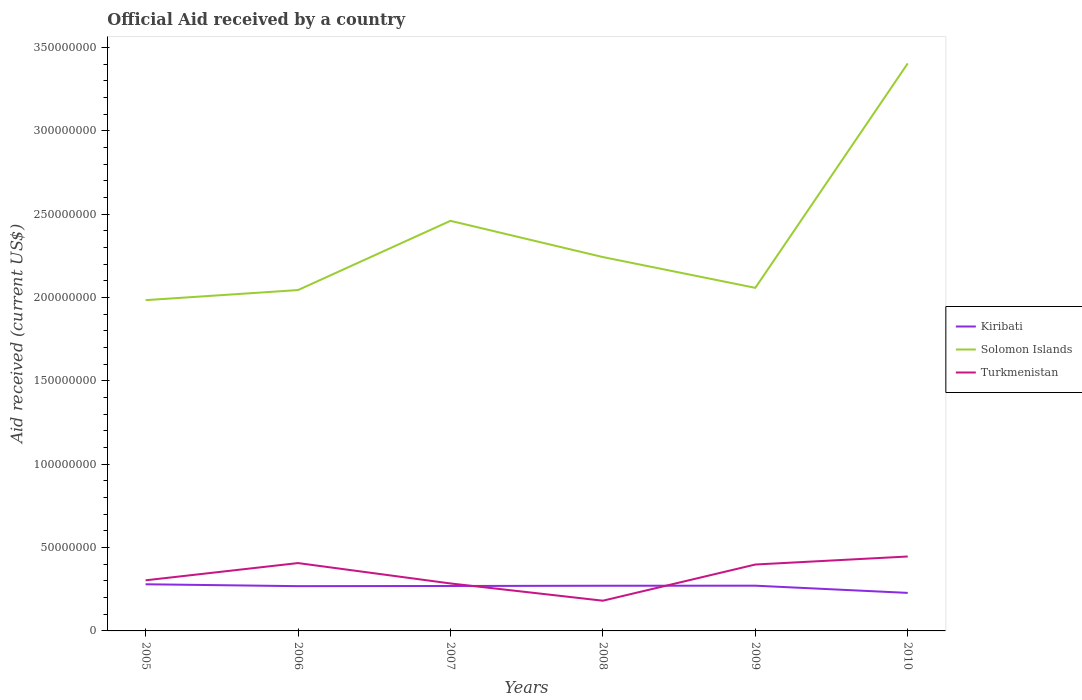How many different coloured lines are there?
Offer a very short reply. 3. Does the line corresponding to Solomon Islands intersect with the line corresponding to Turkmenistan?
Keep it short and to the point. No. Is the number of lines equal to the number of legend labels?
Offer a terse response. Yes. Across all years, what is the maximum net official aid received in Kiribati?
Your response must be concise. 2.28e+07. In which year was the net official aid received in Kiribati maximum?
Your answer should be compact. 2010. What is the total net official aid received in Kiribati in the graph?
Provide a succinct answer. 4.32e+06. What is the difference between the highest and the second highest net official aid received in Turkmenistan?
Offer a very short reply. 2.65e+07. Is the net official aid received in Kiribati strictly greater than the net official aid received in Solomon Islands over the years?
Keep it short and to the point. Yes. Does the graph contain any zero values?
Make the answer very short. No. Does the graph contain grids?
Your answer should be compact. No. Where does the legend appear in the graph?
Give a very brief answer. Center right. How many legend labels are there?
Your answer should be very brief. 3. What is the title of the graph?
Offer a terse response. Official Aid received by a country. What is the label or title of the Y-axis?
Provide a short and direct response. Aid received (current US$). What is the Aid received (current US$) of Kiribati in 2005?
Offer a terse response. 2.80e+07. What is the Aid received (current US$) in Solomon Islands in 2005?
Your answer should be very brief. 1.98e+08. What is the Aid received (current US$) in Turkmenistan in 2005?
Provide a succinct answer. 3.04e+07. What is the Aid received (current US$) in Kiribati in 2006?
Provide a short and direct response. 2.69e+07. What is the Aid received (current US$) of Solomon Islands in 2006?
Keep it short and to the point. 2.05e+08. What is the Aid received (current US$) in Turkmenistan in 2006?
Keep it short and to the point. 4.07e+07. What is the Aid received (current US$) of Kiribati in 2007?
Provide a short and direct response. 2.70e+07. What is the Aid received (current US$) of Solomon Islands in 2007?
Provide a short and direct response. 2.46e+08. What is the Aid received (current US$) of Turkmenistan in 2007?
Provide a short and direct response. 2.85e+07. What is the Aid received (current US$) of Kiribati in 2008?
Provide a short and direct response. 2.71e+07. What is the Aid received (current US$) in Solomon Islands in 2008?
Your answer should be compact. 2.24e+08. What is the Aid received (current US$) of Turkmenistan in 2008?
Make the answer very short. 1.81e+07. What is the Aid received (current US$) of Kiribati in 2009?
Keep it short and to the point. 2.71e+07. What is the Aid received (current US$) of Solomon Islands in 2009?
Your answer should be compact. 2.06e+08. What is the Aid received (current US$) of Turkmenistan in 2009?
Ensure brevity in your answer.  3.98e+07. What is the Aid received (current US$) in Kiribati in 2010?
Your answer should be compact. 2.28e+07. What is the Aid received (current US$) in Solomon Islands in 2010?
Keep it short and to the point. 3.40e+08. What is the Aid received (current US$) of Turkmenistan in 2010?
Provide a short and direct response. 4.46e+07. Across all years, what is the maximum Aid received (current US$) in Kiribati?
Keep it short and to the point. 2.80e+07. Across all years, what is the maximum Aid received (current US$) in Solomon Islands?
Your answer should be compact. 3.40e+08. Across all years, what is the maximum Aid received (current US$) in Turkmenistan?
Provide a succinct answer. 4.46e+07. Across all years, what is the minimum Aid received (current US$) in Kiribati?
Offer a very short reply. 2.28e+07. Across all years, what is the minimum Aid received (current US$) of Solomon Islands?
Your answer should be compact. 1.98e+08. Across all years, what is the minimum Aid received (current US$) of Turkmenistan?
Offer a very short reply. 1.81e+07. What is the total Aid received (current US$) in Kiribati in the graph?
Offer a terse response. 1.59e+08. What is the total Aid received (current US$) in Solomon Islands in the graph?
Your answer should be very brief. 1.42e+09. What is the total Aid received (current US$) in Turkmenistan in the graph?
Ensure brevity in your answer.  2.02e+08. What is the difference between the Aid received (current US$) of Kiribati in 2005 and that in 2006?
Keep it short and to the point. 1.13e+06. What is the difference between the Aid received (current US$) in Solomon Islands in 2005 and that in 2006?
Give a very brief answer. -6.04e+06. What is the difference between the Aid received (current US$) in Turkmenistan in 2005 and that in 2006?
Offer a very short reply. -1.03e+07. What is the difference between the Aid received (current US$) in Kiribati in 2005 and that in 2007?
Your response must be concise. 1.03e+06. What is the difference between the Aid received (current US$) in Solomon Islands in 2005 and that in 2007?
Give a very brief answer. -4.76e+07. What is the difference between the Aid received (current US$) in Turkmenistan in 2005 and that in 2007?
Offer a terse response. 1.89e+06. What is the difference between the Aid received (current US$) of Kiribati in 2005 and that in 2008?
Offer a very short reply. 8.90e+05. What is the difference between the Aid received (current US$) of Solomon Islands in 2005 and that in 2008?
Offer a terse response. -2.58e+07. What is the difference between the Aid received (current US$) in Turkmenistan in 2005 and that in 2008?
Provide a short and direct response. 1.22e+07. What is the difference between the Aid received (current US$) in Kiribati in 2005 and that in 2009?
Provide a succinct answer. 8.50e+05. What is the difference between the Aid received (current US$) in Solomon Islands in 2005 and that in 2009?
Provide a succinct answer. -7.38e+06. What is the difference between the Aid received (current US$) of Turkmenistan in 2005 and that in 2009?
Provide a succinct answer. -9.47e+06. What is the difference between the Aid received (current US$) of Kiribati in 2005 and that in 2010?
Keep it short and to the point. 5.17e+06. What is the difference between the Aid received (current US$) of Solomon Islands in 2005 and that in 2010?
Offer a very short reply. -1.42e+08. What is the difference between the Aid received (current US$) in Turkmenistan in 2005 and that in 2010?
Keep it short and to the point. -1.43e+07. What is the difference between the Aid received (current US$) in Solomon Islands in 2006 and that in 2007?
Make the answer very short. -4.15e+07. What is the difference between the Aid received (current US$) of Turkmenistan in 2006 and that in 2007?
Give a very brief answer. 1.22e+07. What is the difference between the Aid received (current US$) in Kiribati in 2006 and that in 2008?
Offer a very short reply. -2.40e+05. What is the difference between the Aid received (current US$) of Solomon Islands in 2006 and that in 2008?
Provide a succinct answer. -1.98e+07. What is the difference between the Aid received (current US$) in Turkmenistan in 2006 and that in 2008?
Provide a succinct answer. 2.26e+07. What is the difference between the Aid received (current US$) in Kiribati in 2006 and that in 2009?
Provide a short and direct response. -2.80e+05. What is the difference between the Aid received (current US$) in Solomon Islands in 2006 and that in 2009?
Ensure brevity in your answer.  -1.34e+06. What is the difference between the Aid received (current US$) in Turkmenistan in 2006 and that in 2009?
Your answer should be compact. 8.70e+05. What is the difference between the Aid received (current US$) in Kiribati in 2006 and that in 2010?
Your answer should be compact. 4.04e+06. What is the difference between the Aid received (current US$) of Solomon Islands in 2006 and that in 2010?
Offer a very short reply. -1.36e+08. What is the difference between the Aid received (current US$) of Turkmenistan in 2006 and that in 2010?
Provide a short and direct response. -3.94e+06. What is the difference between the Aid received (current US$) in Solomon Islands in 2007 and that in 2008?
Give a very brief answer. 2.17e+07. What is the difference between the Aid received (current US$) of Turkmenistan in 2007 and that in 2008?
Make the answer very short. 1.04e+07. What is the difference between the Aid received (current US$) in Kiribati in 2007 and that in 2009?
Give a very brief answer. -1.80e+05. What is the difference between the Aid received (current US$) in Solomon Islands in 2007 and that in 2009?
Make the answer very short. 4.02e+07. What is the difference between the Aid received (current US$) of Turkmenistan in 2007 and that in 2009?
Ensure brevity in your answer.  -1.14e+07. What is the difference between the Aid received (current US$) of Kiribati in 2007 and that in 2010?
Keep it short and to the point. 4.14e+06. What is the difference between the Aid received (current US$) in Solomon Islands in 2007 and that in 2010?
Keep it short and to the point. -9.44e+07. What is the difference between the Aid received (current US$) of Turkmenistan in 2007 and that in 2010?
Give a very brief answer. -1.62e+07. What is the difference between the Aid received (current US$) in Kiribati in 2008 and that in 2009?
Your answer should be very brief. -4.00e+04. What is the difference between the Aid received (current US$) in Solomon Islands in 2008 and that in 2009?
Provide a succinct answer. 1.85e+07. What is the difference between the Aid received (current US$) of Turkmenistan in 2008 and that in 2009?
Ensure brevity in your answer.  -2.17e+07. What is the difference between the Aid received (current US$) in Kiribati in 2008 and that in 2010?
Provide a succinct answer. 4.28e+06. What is the difference between the Aid received (current US$) in Solomon Islands in 2008 and that in 2010?
Your answer should be very brief. -1.16e+08. What is the difference between the Aid received (current US$) of Turkmenistan in 2008 and that in 2010?
Provide a succinct answer. -2.65e+07. What is the difference between the Aid received (current US$) of Kiribati in 2009 and that in 2010?
Offer a terse response. 4.32e+06. What is the difference between the Aid received (current US$) in Solomon Islands in 2009 and that in 2010?
Ensure brevity in your answer.  -1.35e+08. What is the difference between the Aid received (current US$) in Turkmenistan in 2009 and that in 2010?
Give a very brief answer. -4.81e+06. What is the difference between the Aid received (current US$) in Kiribati in 2005 and the Aid received (current US$) in Solomon Islands in 2006?
Provide a succinct answer. -1.77e+08. What is the difference between the Aid received (current US$) of Kiribati in 2005 and the Aid received (current US$) of Turkmenistan in 2006?
Your answer should be compact. -1.27e+07. What is the difference between the Aid received (current US$) of Solomon Islands in 2005 and the Aid received (current US$) of Turkmenistan in 2006?
Give a very brief answer. 1.58e+08. What is the difference between the Aid received (current US$) in Kiribati in 2005 and the Aid received (current US$) in Solomon Islands in 2007?
Make the answer very short. -2.18e+08. What is the difference between the Aid received (current US$) in Kiribati in 2005 and the Aid received (current US$) in Turkmenistan in 2007?
Offer a terse response. -4.90e+05. What is the difference between the Aid received (current US$) of Solomon Islands in 2005 and the Aid received (current US$) of Turkmenistan in 2007?
Provide a short and direct response. 1.70e+08. What is the difference between the Aid received (current US$) of Kiribati in 2005 and the Aid received (current US$) of Solomon Islands in 2008?
Provide a short and direct response. -1.96e+08. What is the difference between the Aid received (current US$) of Kiribati in 2005 and the Aid received (current US$) of Turkmenistan in 2008?
Offer a terse response. 9.86e+06. What is the difference between the Aid received (current US$) in Solomon Islands in 2005 and the Aid received (current US$) in Turkmenistan in 2008?
Give a very brief answer. 1.80e+08. What is the difference between the Aid received (current US$) in Kiribati in 2005 and the Aid received (current US$) in Solomon Islands in 2009?
Your answer should be compact. -1.78e+08. What is the difference between the Aid received (current US$) in Kiribati in 2005 and the Aid received (current US$) in Turkmenistan in 2009?
Offer a terse response. -1.18e+07. What is the difference between the Aid received (current US$) of Solomon Islands in 2005 and the Aid received (current US$) of Turkmenistan in 2009?
Your answer should be compact. 1.59e+08. What is the difference between the Aid received (current US$) in Kiribati in 2005 and the Aid received (current US$) in Solomon Islands in 2010?
Ensure brevity in your answer.  -3.12e+08. What is the difference between the Aid received (current US$) of Kiribati in 2005 and the Aid received (current US$) of Turkmenistan in 2010?
Offer a terse response. -1.67e+07. What is the difference between the Aid received (current US$) of Solomon Islands in 2005 and the Aid received (current US$) of Turkmenistan in 2010?
Provide a succinct answer. 1.54e+08. What is the difference between the Aid received (current US$) in Kiribati in 2006 and the Aid received (current US$) in Solomon Islands in 2007?
Offer a terse response. -2.19e+08. What is the difference between the Aid received (current US$) of Kiribati in 2006 and the Aid received (current US$) of Turkmenistan in 2007?
Your answer should be compact. -1.62e+06. What is the difference between the Aid received (current US$) of Solomon Islands in 2006 and the Aid received (current US$) of Turkmenistan in 2007?
Offer a very short reply. 1.76e+08. What is the difference between the Aid received (current US$) of Kiribati in 2006 and the Aid received (current US$) of Solomon Islands in 2008?
Give a very brief answer. -1.97e+08. What is the difference between the Aid received (current US$) of Kiribati in 2006 and the Aid received (current US$) of Turkmenistan in 2008?
Ensure brevity in your answer.  8.73e+06. What is the difference between the Aid received (current US$) in Solomon Islands in 2006 and the Aid received (current US$) in Turkmenistan in 2008?
Offer a very short reply. 1.86e+08. What is the difference between the Aid received (current US$) in Kiribati in 2006 and the Aid received (current US$) in Solomon Islands in 2009?
Offer a terse response. -1.79e+08. What is the difference between the Aid received (current US$) in Kiribati in 2006 and the Aid received (current US$) in Turkmenistan in 2009?
Ensure brevity in your answer.  -1.30e+07. What is the difference between the Aid received (current US$) in Solomon Islands in 2006 and the Aid received (current US$) in Turkmenistan in 2009?
Keep it short and to the point. 1.65e+08. What is the difference between the Aid received (current US$) in Kiribati in 2006 and the Aid received (current US$) in Solomon Islands in 2010?
Make the answer very short. -3.14e+08. What is the difference between the Aid received (current US$) in Kiribati in 2006 and the Aid received (current US$) in Turkmenistan in 2010?
Your response must be concise. -1.78e+07. What is the difference between the Aid received (current US$) in Solomon Islands in 2006 and the Aid received (current US$) in Turkmenistan in 2010?
Your answer should be compact. 1.60e+08. What is the difference between the Aid received (current US$) of Kiribati in 2007 and the Aid received (current US$) of Solomon Islands in 2008?
Provide a short and direct response. -1.97e+08. What is the difference between the Aid received (current US$) in Kiribati in 2007 and the Aid received (current US$) in Turkmenistan in 2008?
Ensure brevity in your answer.  8.83e+06. What is the difference between the Aid received (current US$) in Solomon Islands in 2007 and the Aid received (current US$) in Turkmenistan in 2008?
Your answer should be very brief. 2.28e+08. What is the difference between the Aid received (current US$) of Kiribati in 2007 and the Aid received (current US$) of Solomon Islands in 2009?
Offer a very short reply. -1.79e+08. What is the difference between the Aid received (current US$) in Kiribati in 2007 and the Aid received (current US$) in Turkmenistan in 2009?
Provide a succinct answer. -1.29e+07. What is the difference between the Aid received (current US$) of Solomon Islands in 2007 and the Aid received (current US$) of Turkmenistan in 2009?
Provide a short and direct response. 2.06e+08. What is the difference between the Aid received (current US$) in Kiribati in 2007 and the Aid received (current US$) in Solomon Islands in 2010?
Provide a succinct answer. -3.14e+08. What is the difference between the Aid received (current US$) of Kiribati in 2007 and the Aid received (current US$) of Turkmenistan in 2010?
Give a very brief answer. -1.77e+07. What is the difference between the Aid received (current US$) in Solomon Islands in 2007 and the Aid received (current US$) in Turkmenistan in 2010?
Provide a short and direct response. 2.01e+08. What is the difference between the Aid received (current US$) of Kiribati in 2008 and the Aid received (current US$) of Solomon Islands in 2009?
Offer a terse response. -1.79e+08. What is the difference between the Aid received (current US$) of Kiribati in 2008 and the Aid received (current US$) of Turkmenistan in 2009?
Offer a terse response. -1.27e+07. What is the difference between the Aid received (current US$) in Solomon Islands in 2008 and the Aid received (current US$) in Turkmenistan in 2009?
Provide a succinct answer. 1.84e+08. What is the difference between the Aid received (current US$) of Kiribati in 2008 and the Aid received (current US$) of Solomon Islands in 2010?
Offer a terse response. -3.13e+08. What is the difference between the Aid received (current US$) of Kiribati in 2008 and the Aid received (current US$) of Turkmenistan in 2010?
Provide a succinct answer. -1.76e+07. What is the difference between the Aid received (current US$) of Solomon Islands in 2008 and the Aid received (current US$) of Turkmenistan in 2010?
Make the answer very short. 1.80e+08. What is the difference between the Aid received (current US$) of Kiribati in 2009 and the Aid received (current US$) of Solomon Islands in 2010?
Keep it short and to the point. -3.13e+08. What is the difference between the Aid received (current US$) in Kiribati in 2009 and the Aid received (current US$) in Turkmenistan in 2010?
Give a very brief answer. -1.75e+07. What is the difference between the Aid received (current US$) of Solomon Islands in 2009 and the Aid received (current US$) of Turkmenistan in 2010?
Your answer should be compact. 1.61e+08. What is the average Aid received (current US$) in Kiribati per year?
Ensure brevity in your answer.  2.65e+07. What is the average Aid received (current US$) in Solomon Islands per year?
Provide a short and direct response. 2.37e+08. What is the average Aid received (current US$) of Turkmenistan per year?
Ensure brevity in your answer.  3.37e+07. In the year 2005, what is the difference between the Aid received (current US$) of Kiribati and Aid received (current US$) of Solomon Islands?
Your answer should be compact. -1.70e+08. In the year 2005, what is the difference between the Aid received (current US$) in Kiribati and Aid received (current US$) in Turkmenistan?
Offer a terse response. -2.38e+06. In the year 2005, what is the difference between the Aid received (current US$) in Solomon Islands and Aid received (current US$) in Turkmenistan?
Your response must be concise. 1.68e+08. In the year 2006, what is the difference between the Aid received (current US$) of Kiribati and Aid received (current US$) of Solomon Islands?
Provide a succinct answer. -1.78e+08. In the year 2006, what is the difference between the Aid received (current US$) in Kiribati and Aid received (current US$) in Turkmenistan?
Ensure brevity in your answer.  -1.38e+07. In the year 2006, what is the difference between the Aid received (current US$) in Solomon Islands and Aid received (current US$) in Turkmenistan?
Offer a very short reply. 1.64e+08. In the year 2007, what is the difference between the Aid received (current US$) in Kiribati and Aid received (current US$) in Solomon Islands?
Ensure brevity in your answer.  -2.19e+08. In the year 2007, what is the difference between the Aid received (current US$) of Kiribati and Aid received (current US$) of Turkmenistan?
Offer a very short reply. -1.52e+06. In the year 2007, what is the difference between the Aid received (current US$) of Solomon Islands and Aid received (current US$) of Turkmenistan?
Offer a very short reply. 2.18e+08. In the year 2008, what is the difference between the Aid received (current US$) in Kiribati and Aid received (current US$) in Solomon Islands?
Your answer should be very brief. -1.97e+08. In the year 2008, what is the difference between the Aid received (current US$) of Kiribati and Aid received (current US$) of Turkmenistan?
Make the answer very short. 8.97e+06. In the year 2008, what is the difference between the Aid received (current US$) in Solomon Islands and Aid received (current US$) in Turkmenistan?
Your answer should be compact. 2.06e+08. In the year 2009, what is the difference between the Aid received (current US$) in Kiribati and Aid received (current US$) in Solomon Islands?
Keep it short and to the point. -1.79e+08. In the year 2009, what is the difference between the Aid received (current US$) of Kiribati and Aid received (current US$) of Turkmenistan?
Ensure brevity in your answer.  -1.27e+07. In the year 2009, what is the difference between the Aid received (current US$) in Solomon Islands and Aid received (current US$) in Turkmenistan?
Offer a very short reply. 1.66e+08. In the year 2010, what is the difference between the Aid received (current US$) in Kiribati and Aid received (current US$) in Solomon Islands?
Provide a succinct answer. -3.18e+08. In the year 2010, what is the difference between the Aid received (current US$) in Kiribati and Aid received (current US$) in Turkmenistan?
Your response must be concise. -2.18e+07. In the year 2010, what is the difference between the Aid received (current US$) of Solomon Islands and Aid received (current US$) of Turkmenistan?
Offer a terse response. 2.96e+08. What is the ratio of the Aid received (current US$) of Kiribati in 2005 to that in 2006?
Offer a terse response. 1.04. What is the ratio of the Aid received (current US$) of Solomon Islands in 2005 to that in 2006?
Offer a terse response. 0.97. What is the ratio of the Aid received (current US$) of Turkmenistan in 2005 to that in 2006?
Your response must be concise. 0.75. What is the ratio of the Aid received (current US$) of Kiribati in 2005 to that in 2007?
Your response must be concise. 1.04. What is the ratio of the Aid received (current US$) in Solomon Islands in 2005 to that in 2007?
Keep it short and to the point. 0.81. What is the ratio of the Aid received (current US$) in Turkmenistan in 2005 to that in 2007?
Ensure brevity in your answer.  1.07. What is the ratio of the Aid received (current US$) of Kiribati in 2005 to that in 2008?
Offer a very short reply. 1.03. What is the ratio of the Aid received (current US$) in Solomon Islands in 2005 to that in 2008?
Your response must be concise. 0.88. What is the ratio of the Aid received (current US$) in Turkmenistan in 2005 to that in 2008?
Give a very brief answer. 1.68. What is the ratio of the Aid received (current US$) in Kiribati in 2005 to that in 2009?
Provide a short and direct response. 1.03. What is the ratio of the Aid received (current US$) in Solomon Islands in 2005 to that in 2009?
Ensure brevity in your answer.  0.96. What is the ratio of the Aid received (current US$) in Turkmenistan in 2005 to that in 2009?
Provide a short and direct response. 0.76. What is the ratio of the Aid received (current US$) of Kiribati in 2005 to that in 2010?
Your answer should be very brief. 1.23. What is the ratio of the Aid received (current US$) of Solomon Islands in 2005 to that in 2010?
Offer a terse response. 0.58. What is the ratio of the Aid received (current US$) of Turkmenistan in 2005 to that in 2010?
Make the answer very short. 0.68. What is the ratio of the Aid received (current US$) in Solomon Islands in 2006 to that in 2007?
Make the answer very short. 0.83. What is the ratio of the Aid received (current US$) of Turkmenistan in 2006 to that in 2007?
Your answer should be compact. 1.43. What is the ratio of the Aid received (current US$) in Kiribati in 2006 to that in 2008?
Offer a terse response. 0.99. What is the ratio of the Aid received (current US$) in Solomon Islands in 2006 to that in 2008?
Your answer should be very brief. 0.91. What is the ratio of the Aid received (current US$) of Turkmenistan in 2006 to that in 2008?
Provide a short and direct response. 2.25. What is the ratio of the Aid received (current US$) of Kiribati in 2006 to that in 2009?
Provide a short and direct response. 0.99. What is the ratio of the Aid received (current US$) in Turkmenistan in 2006 to that in 2009?
Your answer should be compact. 1.02. What is the ratio of the Aid received (current US$) of Kiribati in 2006 to that in 2010?
Ensure brevity in your answer.  1.18. What is the ratio of the Aid received (current US$) of Solomon Islands in 2006 to that in 2010?
Keep it short and to the point. 0.6. What is the ratio of the Aid received (current US$) in Turkmenistan in 2006 to that in 2010?
Provide a succinct answer. 0.91. What is the ratio of the Aid received (current US$) in Kiribati in 2007 to that in 2008?
Offer a very short reply. 0.99. What is the ratio of the Aid received (current US$) of Solomon Islands in 2007 to that in 2008?
Provide a short and direct response. 1.1. What is the ratio of the Aid received (current US$) of Turkmenistan in 2007 to that in 2008?
Offer a very short reply. 1.57. What is the ratio of the Aid received (current US$) in Kiribati in 2007 to that in 2009?
Make the answer very short. 0.99. What is the ratio of the Aid received (current US$) in Solomon Islands in 2007 to that in 2009?
Ensure brevity in your answer.  1.2. What is the ratio of the Aid received (current US$) of Turkmenistan in 2007 to that in 2009?
Provide a short and direct response. 0.71. What is the ratio of the Aid received (current US$) of Kiribati in 2007 to that in 2010?
Keep it short and to the point. 1.18. What is the ratio of the Aid received (current US$) of Solomon Islands in 2007 to that in 2010?
Your response must be concise. 0.72. What is the ratio of the Aid received (current US$) of Turkmenistan in 2007 to that in 2010?
Offer a terse response. 0.64. What is the ratio of the Aid received (current US$) in Solomon Islands in 2008 to that in 2009?
Your answer should be compact. 1.09. What is the ratio of the Aid received (current US$) in Turkmenistan in 2008 to that in 2009?
Provide a succinct answer. 0.46. What is the ratio of the Aid received (current US$) of Kiribati in 2008 to that in 2010?
Your response must be concise. 1.19. What is the ratio of the Aid received (current US$) of Solomon Islands in 2008 to that in 2010?
Ensure brevity in your answer.  0.66. What is the ratio of the Aid received (current US$) of Turkmenistan in 2008 to that in 2010?
Give a very brief answer. 0.41. What is the ratio of the Aid received (current US$) in Kiribati in 2009 to that in 2010?
Your answer should be very brief. 1.19. What is the ratio of the Aid received (current US$) in Solomon Islands in 2009 to that in 2010?
Offer a very short reply. 0.6. What is the ratio of the Aid received (current US$) in Turkmenistan in 2009 to that in 2010?
Give a very brief answer. 0.89. What is the difference between the highest and the second highest Aid received (current US$) of Kiribati?
Your response must be concise. 8.50e+05. What is the difference between the highest and the second highest Aid received (current US$) of Solomon Islands?
Your answer should be very brief. 9.44e+07. What is the difference between the highest and the second highest Aid received (current US$) of Turkmenistan?
Provide a succinct answer. 3.94e+06. What is the difference between the highest and the lowest Aid received (current US$) of Kiribati?
Your response must be concise. 5.17e+06. What is the difference between the highest and the lowest Aid received (current US$) in Solomon Islands?
Your answer should be very brief. 1.42e+08. What is the difference between the highest and the lowest Aid received (current US$) in Turkmenistan?
Ensure brevity in your answer.  2.65e+07. 